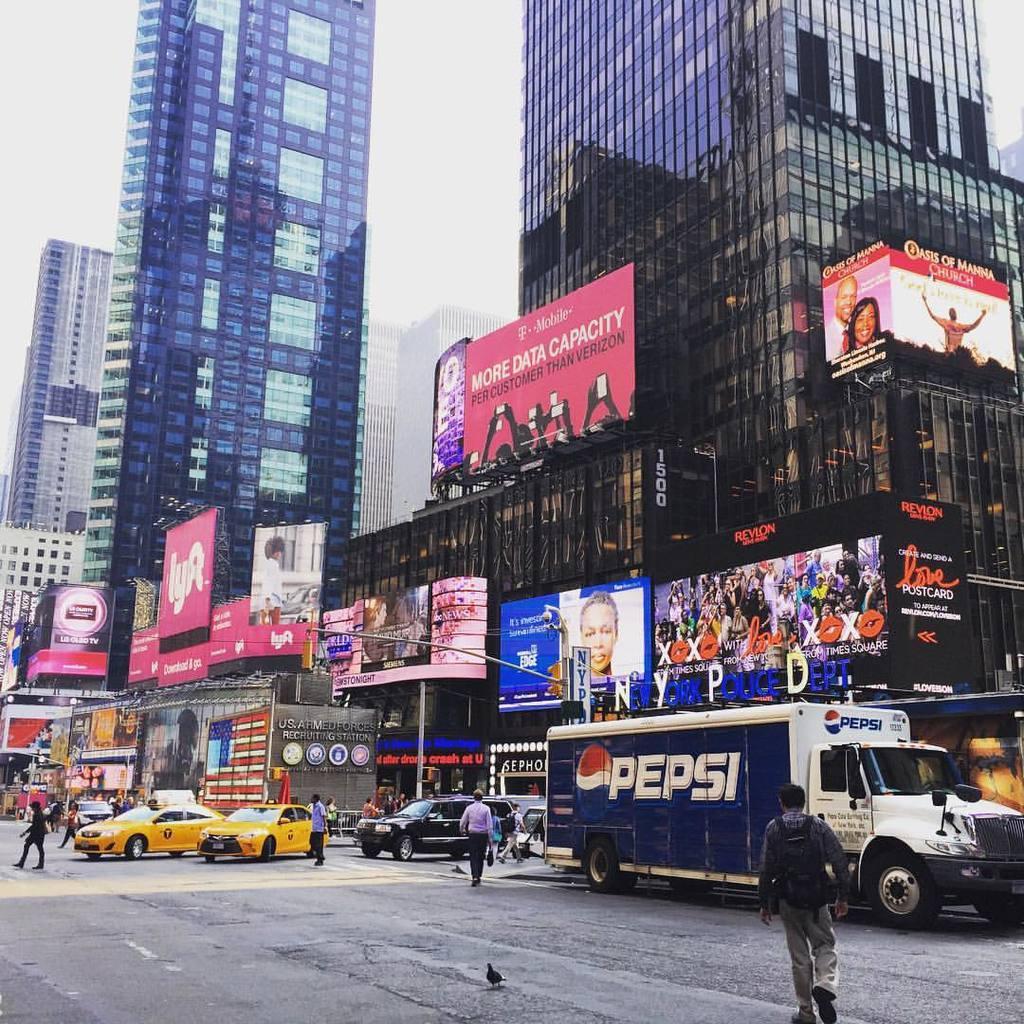In one or two sentences, can you explain what this image depicts? This picture is clicked outside. In the foreground we can see the group of persons and the vehicles. In the center we can see the buildings and there are some boards attached to the buildings and we can see the text and the pictures of some persons on the boards. In the background there is a sky and the buildings. 